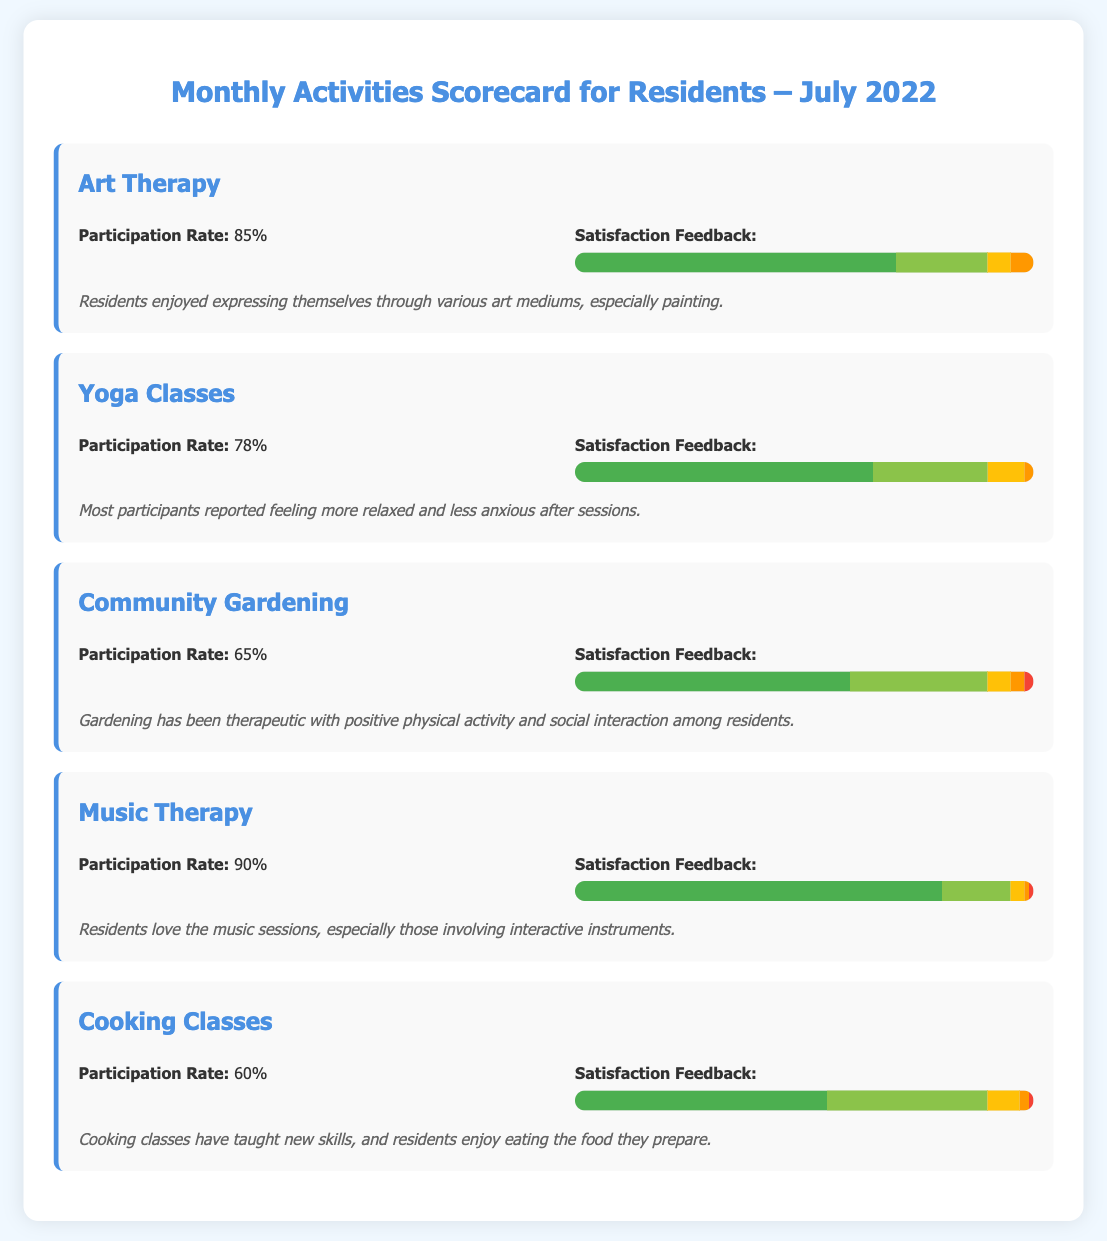What is the participation rate for Art Therapy? The participation rate for Art Therapy is provided in the document as 85%.
Answer: 85% What is the satisfaction level for Music Therapy that received the highest response? The highest satisfaction level for Music Therapy is indicated as 80% for very satisfied residents.
Answer: 80% How many activities had a participation rate of 60% or lower? The document lists Cooking Classes and Community Gardening with participation rates of 60% and 65%, respectively, totaling two activities.
Answer: 2 Which activity had the lowest satisfaction feedback for the dissatisfied category? The activity with the lowest level of dissatisfaction reported is Music Therapy, with only 1% dissatisfied.
Answer: 1% What did residents particularly enjoy about Cooking Classes? The document notes that residents enjoy eating the food they prepare as part of the Cooking Classes.
Answer: Eating the food they prepare Which activity had the highest participation rate? The document illustrates that Music Therapy had the highest participation rate at 90%.
Answer: 90% How many residents reported being neutral about their satisfaction in the Yoga Classes? The satisfaction level for Yoga Classes shows 8% of participants reported being neutral.
Answer: 8% What common benefit did residents report from Yoga Classes? The document refers to residents feeling more relaxed and less anxious as a benefit of Yoga Classes.
Answer: More relaxed and less anxious What overall theme is expressed in the comments for Community Gardening? The comments reflect on community gardening being therapeutic along with promoting positive physical activity.
Answer: Therapeutic and positive physical activity 